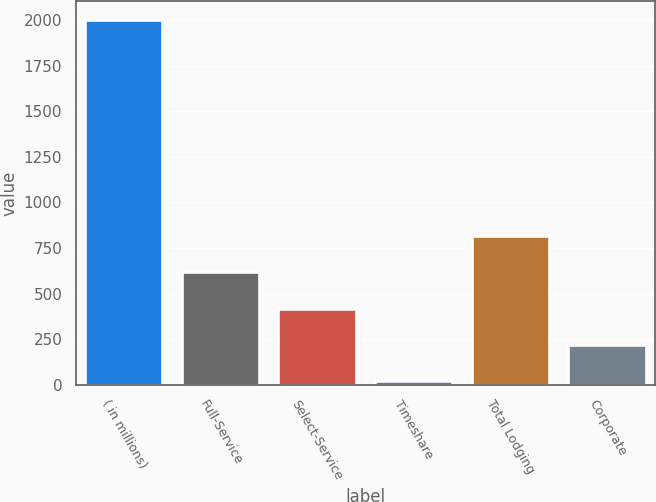<chart> <loc_0><loc_0><loc_500><loc_500><bar_chart><fcel>( in millions)<fcel>Full-Service<fcel>Select-Service<fcel>Timeshare<fcel>Total Lodging<fcel>Corporate<nl><fcel>2003<fcel>616.3<fcel>418.2<fcel>22<fcel>814.4<fcel>220.1<nl></chart> 